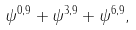<formula> <loc_0><loc_0><loc_500><loc_500>\psi ^ { 0 , 9 } + \psi ^ { 3 , 9 } + \psi ^ { 6 , 9 } ,</formula> 